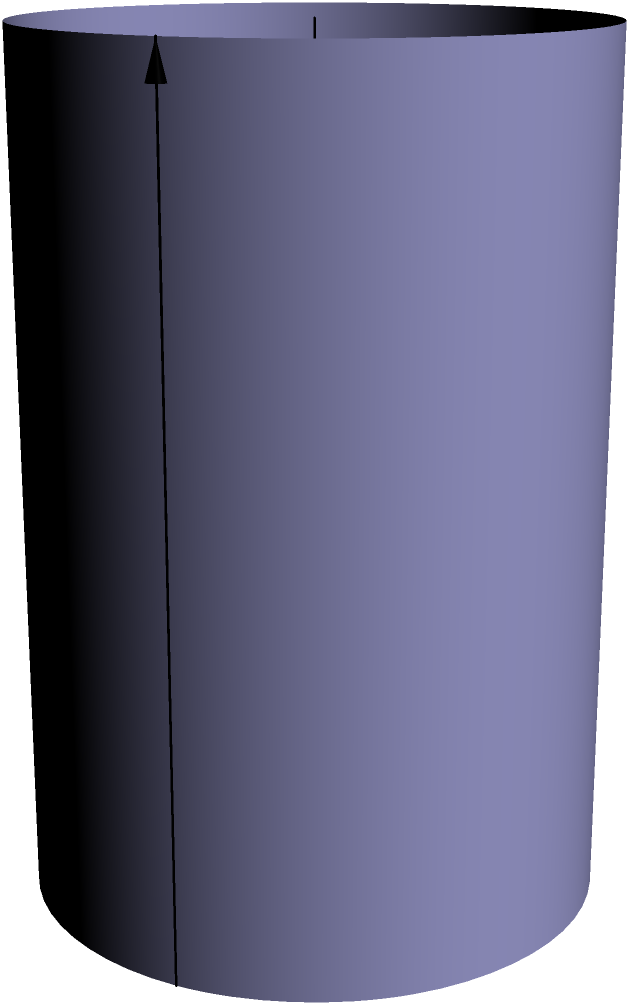As a federal agent investigating illegal moonshine operations, you've discovered a hidden stash of cylindrical barrels. One particular barrel has a radius of 18 inches and a height of 36 inches. What is the volume of moonshine this barrel can hold in cubic feet? (Use $\pi \approx 3.14$ and round your answer to two decimal places.) To calculate the volume of a cylindrical barrel, we'll follow these steps:

1) The formula for the volume of a cylinder is:
   $$V = \pi r^2 h$$
   where $V$ is volume, $r$ is radius, and $h$ is height.

2) We're given:
   Radius $(r) = 18$ inches
   Height $(h) = 36$ inches

3) Let's substitute these values into the formula:
   $$V = \pi (18^2) (36)$$

4) Calculate the squared radius:
   $$V = \pi (324) (36)$$

5) Multiply:
   $$V = \pi (11,664)$$

6) Use $\pi \approx 3.14$:
   $$V \approx 3.14 (11,664) = 36,624.96$$

7) This result is in cubic inches. To convert to cubic feet, divide by 1728 (12^3):
   $$V \approx 36,624.96 \div 1728 \approx 21.19$$

8) Rounding to two decimal places:
   $$V \approx 21.19 \text{ cubic feet}$$
Answer: 21.19 cubic feet 